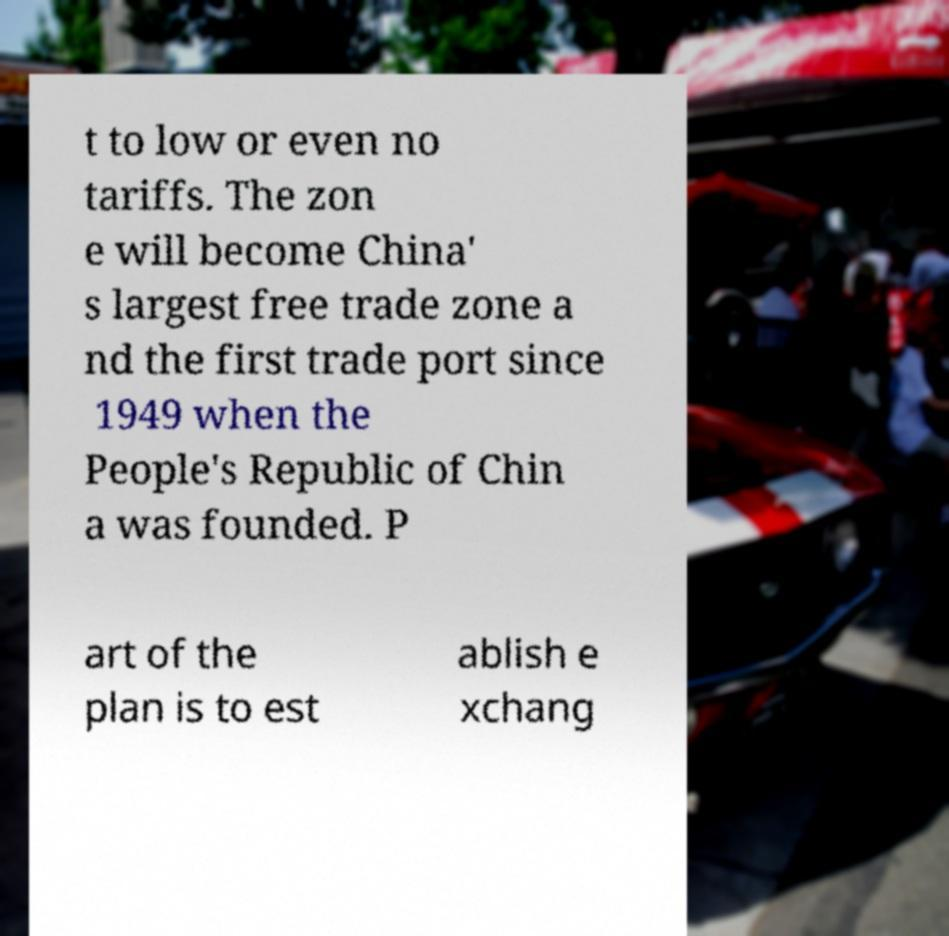Please identify and transcribe the text found in this image. t to low or even no tariffs. The zon e will become China' s largest free trade zone a nd the first trade port since 1949 when the People's Republic of Chin a was founded. P art of the plan is to est ablish e xchang 